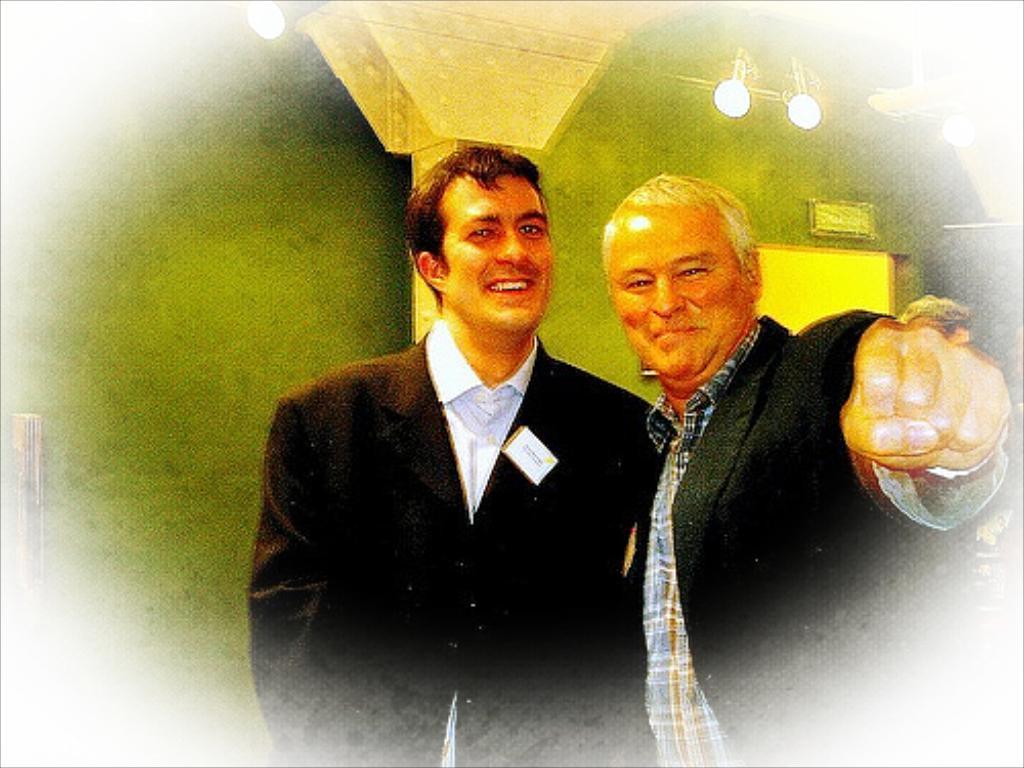Please provide a concise description of this image. There is an image in which, there is a person in black color suit smiling and standing near another person who is smiling and standing. In the background, there are lights attached to the roof, there is a pillar and there is green color wall. 